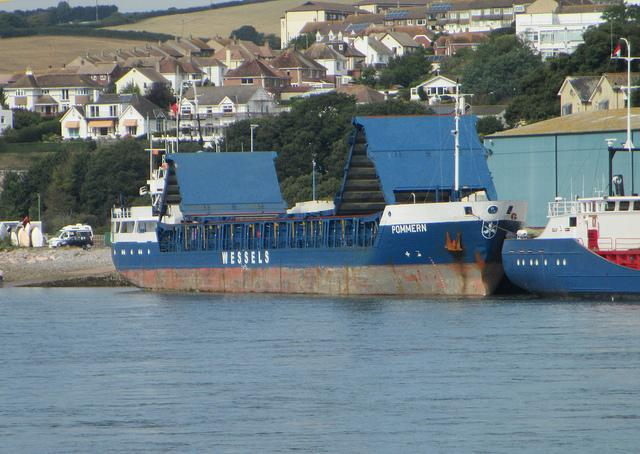The place where these ships are docked is known as?

Choices:
A) harbor
B) quay
C) port
D) wharf port 